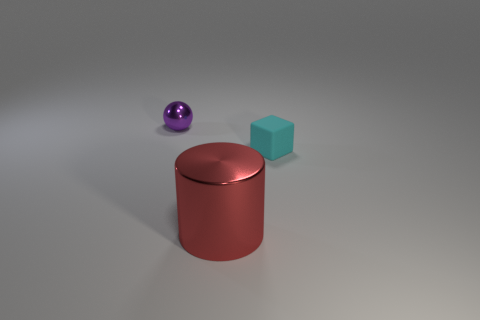Add 2 brown matte blocks. How many objects exist? 5 Subtract 1 cylinders. How many cylinders are left? 0 Add 1 large red cylinders. How many large red cylinders are left? 2 Add 1 purple balls. How many purple balls exist? 2 Subtract 0 red blocks. How many objects are left? 3 Subtract all cylinders. How many objects are left? 2 Subtract all tiny cubes. Subtract all cyan blocks. How many objects are left? 1 